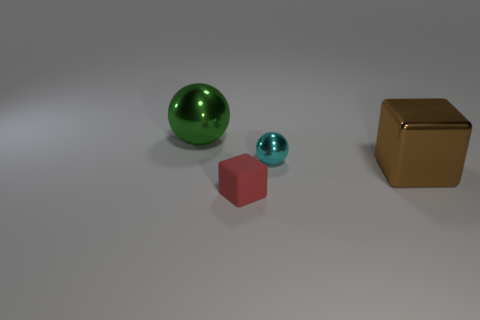What number of things are either things right of the red rubber object or small metallic cylinders?
Provide a succinct answer. 2. There is a thing that is both left of the cyan ball and behind the large brown metal object; what is its size?
Give a very brief answer. Large. How many other objects are the same size as the green shiny sphere?
Your answer should be compact. 1. There is a big shiny thing that is on the right side of the tiny thing in front of the tiny thing that is right of the red object; what color is it?
Your answer should be compact. Brown. The object that is both in front of the small metal object and behind the red object has what shape?
Ensure brevity in your answer.  Cube. How many other things are there of the same shape as the small red object?
Give a very brief answer. 1. There is a big metal object in front of the small object to the right of the small object that is in front of the brown shiny object; what is its shape?
Keep it short and to the point. Cube. How many objects are green metallic spheres or brown metallic things on the right side of the matte object?
Your response must be concise. 2. There is a thing right of the small shiny ball; is its shape the same as the small object that is on the left side of the tiny sphere?
Your response must be concise. Yes. What number of things are either large yellow rubber objects or big metal objects?
Keep it short and to the point. 2. 